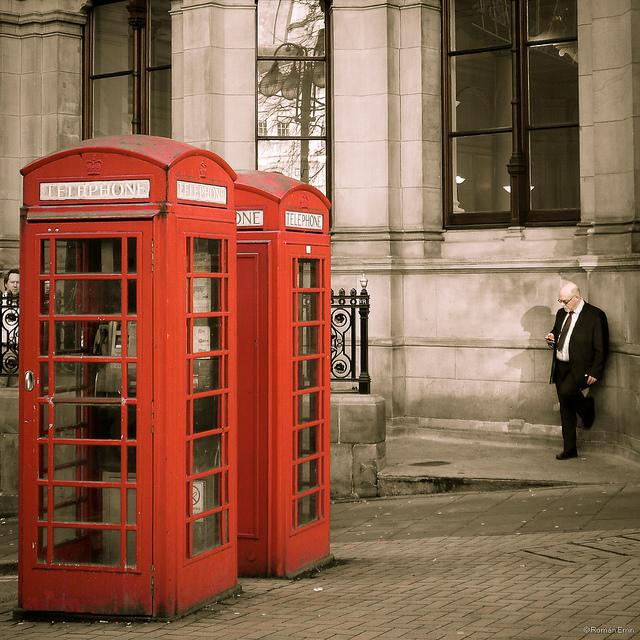Are these phone booths American?
Be succinct. No. Could the man be waiting to use a phone?
Be succinct. No. What color are these phone booths?
Short answer required. Red. What would help if there is a fire?
Be succinct. Water. How many outhouses are in this scene?
Give a very brief answer. 0. 